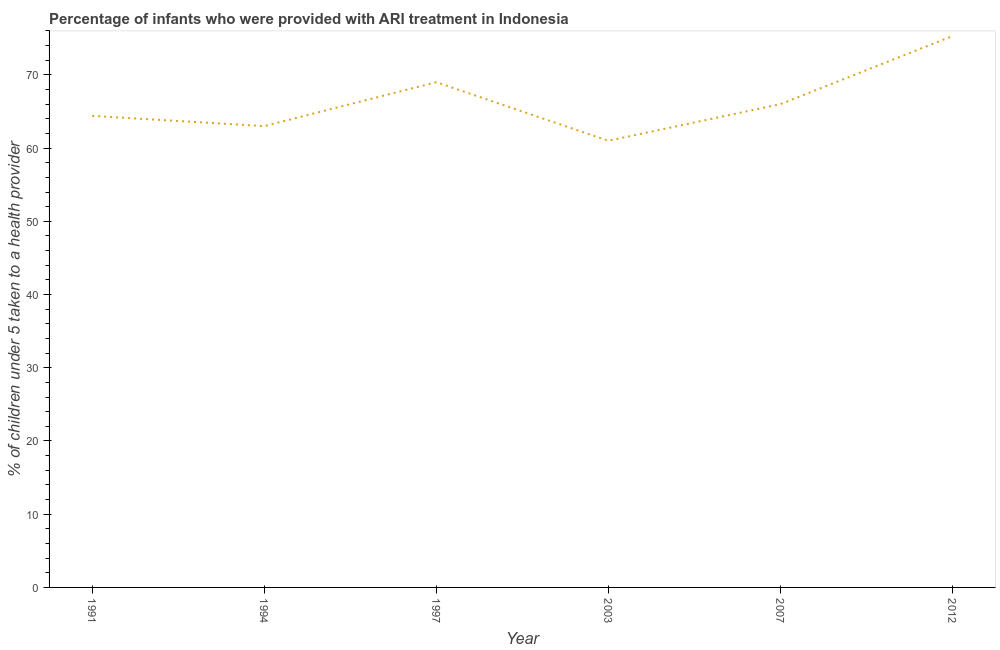What is the percentage of children who were provided with ari treatment in 1994?
Keep it short and to the point. 63. Across all years, what is the maximum percentage of children who were provided with ari treatment?
Provide a short and direct response. 75.3. Across all years, what is the minimum percentage of children who were provided with ari treatment?
Your response must be concise. 61. In which year was the percentage of children who were provided with ari treatment minimum?
Your response must be concise. 2003. What is the sum of the percentage of children who were provided with ari treatment?
Your answer should be very brief. 398.7. What is the difference between the percentage of children who were provided with ari treatment in 1997 and 2012?
Ensure brevity in your answer.  -6.3. What is the average percentage of children who were provided with ari treatment per year?
Provide a short and direct response. 66.45. What is the median percentage of children who were provided with ari treatment?
Make the answer very short. 65.2. In how many years, is the percentage of children who were provided with ari treatment greater than 22 %?
Give a very brief answer. 6. What is the ratio of the percentage of children who were provided with ari treatment in 2003 to that in 2007?
Ensure brevity in your answer.  0.92. What is the difference between the highest and the second highest percentage of children who were provided with ari treatment?
Offer a terse response. 6.3. Is the sum of the percentage of children who were provided with ari treatment in 1997 and 2007 greater than the maximum percentage of children who were provided with ari treatment across all years?
Offer a very short reply. Yes. What is the difference between the highest and the lowest percentage of children who were provided with ari treatment?
Offer a very short reply. 14.3. How many years are there in the graph?
Provide a short and direct response. 6. Does the graph contain grids?
Your answer should be compact. No. What is the title of the graph?
Your answer should be compact. Percentage of infants who were provided with ARI treatment in Indonesia. What is the label or title of the X-axis?
Your answer should be very brief. Year. What is the label or title of the Y-axis?
Make the answer very short. % of children under 5 taken to a health provider. What is the % of children under 5 taken to a health provider in 1991?
Your response must be concise. 64.4. What is the % of children under 5 taken to a health provider of 2003?
Provide a succinct answer. 61. What is the % of children under 5 taken to a health provider in 2012?
Your response must be concise. 75.3. What is the difference between the % of children under 5 taken to a health provider in 1991 and 1997?
Provide a short and direct response. -4.6. What is the difference between the % of children under 5 taken to a health provider in 1991 and 2003?
Provide a short and direct response. 3.4. What is the difference between the % of children under 5 taken to a health provider in 1991 and 2007?
Keep it short and to the point. -1.6. What is the difference between the % of children under 5 taken to a health provider in 1991 and 2012?
Give a very brief answer. -10.9. What is the difference between the % of children under 5 taken to a health provider in 1994 and 1997?
Offer a very short reply. -6. What is the difference between the % of children under 5 taken to a health provider in 1994 and 2012?
Keep it short and to the point. -12.3. What is the difference between the % of children under 5 taken to a health provider in 1997 and 2003?
Offer a terse response. 8. What is the difference between the % of children under 5 taken to a health provider in 1997 and 2012?
Your response must be concise. -6.3. What is the difference between the % of children under 5 taken to a health provider in 2003 and 2012?
Your response must be concise. -14.3. What is the ratio of the % of children under 5 taken to a health provider in 1991 to that in 1997?
Keep it short and to the point. 0.93. What is the ratio of the % of children under 5 taken to a health provider in 1991 to that in 2003?
Your response must be concise. 1.06. What is the ratio of the % of children under 5 taken to a health provider in 1991 to that in 2007?
Your answer should be compact. 0.98. What is the ratio of the % of children under 5 taken to a health provider in 1991 to that in 2012?
Keep it short and to the point. 0.85. What is the ratio of the % of children under 5 taken to a health provider in 1994 to that in 1997?
Provide a short and direct response. 0.91. What is the ratio of the % of children under 5 taken to a health provider in 1994 to that in 2003?
Your answer should be very brief. 1.03. What is the ratio of the % of children under 5 taken to a health provider in 1994 to that in 2007?
Keep it short and to the point. 0.95. What is the ratio of the % of children under 5 taken to a health provider in 1994 to that in 2012?
Your answer should be compact. 0.84. What is the ratio of the % of children under 5 taken to a health provider in 1997 to that in 2003?
Give a very brief answer. 1.13. What is the ratio of the % of children under 5 taken to a health provider in 1997 to that in 2007?
Provide a succinct answer. 1.04. What is the ratio of the % of children under 5 taken to a health provider in 1997 to that in 2012?
Keep it short and to the point. 0.92. What is the ratio of the % of children under 5 taken to a health provider in 2003 to that in 2007?
Your answer should be compact. 0.92. What is the ratio of the % of children under 5 taken to a health provider in 2003 to that in 2012?
Your response must be concise. 0.81. What is the ratio of the % of children under 5 taken to a health provider in 2007 to that in 2012?
Make the answer very short. 0.88. 